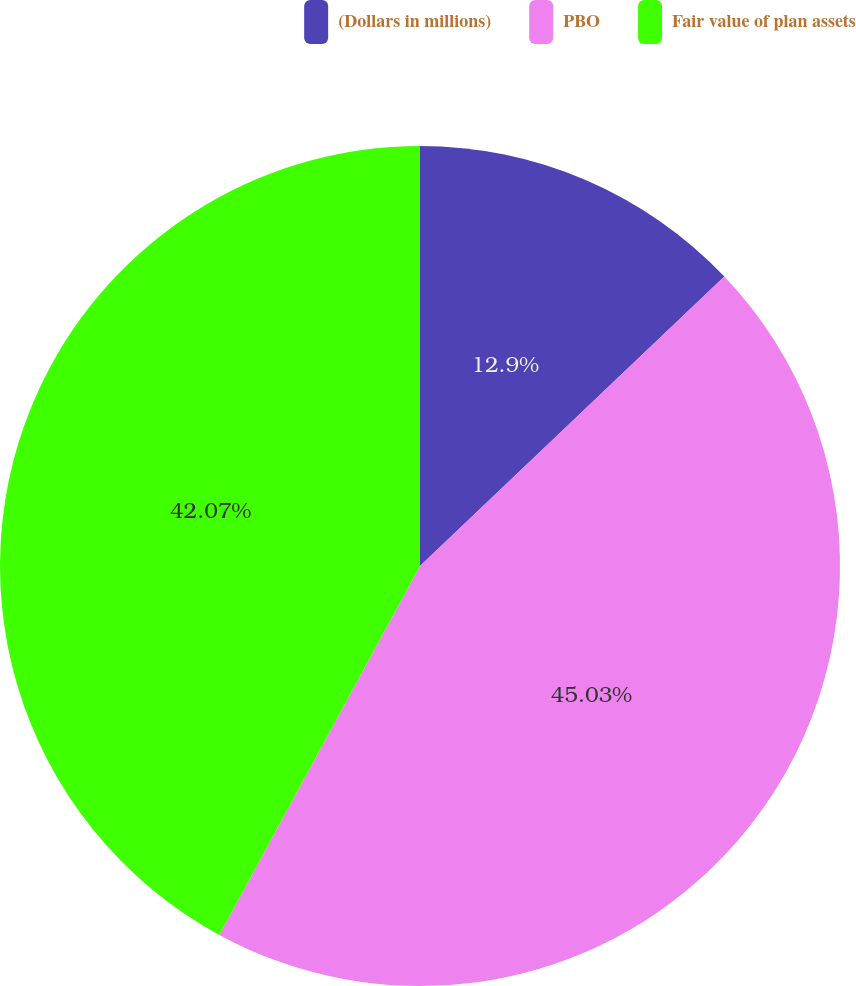<chart> <loc_0><loc_0><loc_500><loc_500><pie_chart><fcel>(Dollars in millions)<fcel>PBO<fcel>Fair value of plan assets<nl><fcel>12.9%<fcel>45.03%<fcel>42.07%<nl></chart> 